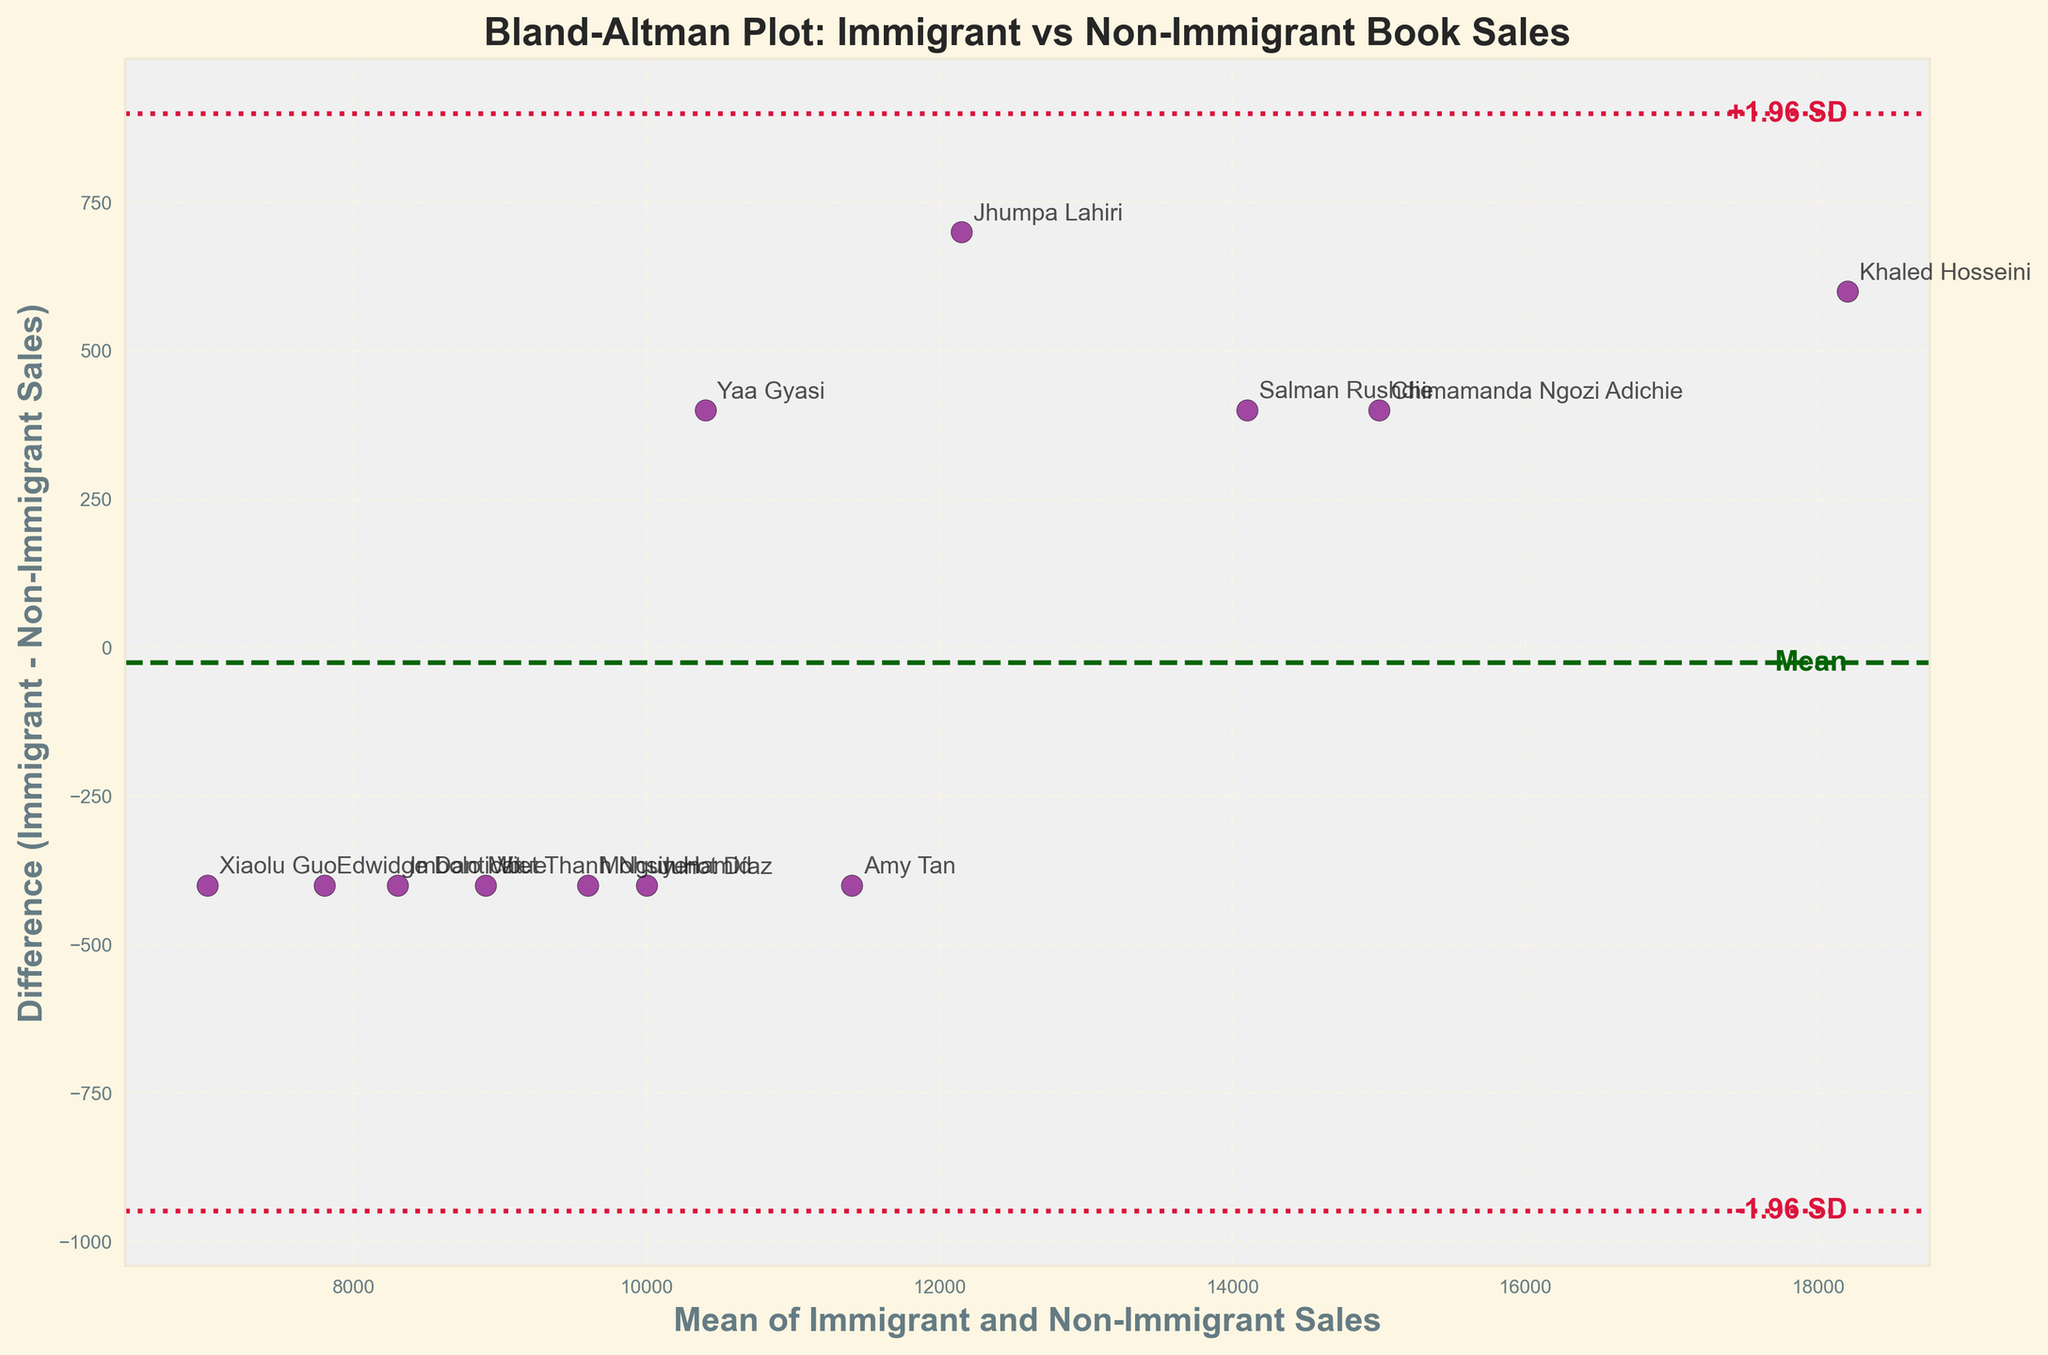What is the title of the plot? The title is displayed at the top of the plot and it reads "Bland-Altman Plot: Immigrant vs Non-Immigrant Book Sales."
Answer: Bland-Altman Plot: Immigrant vs Non-Immigrant Book Sales How many authors are represented in the plot? Each data point in the scatter plot represents an author. By counting these points or the annotations, we find there are 12 authors.
Answer: 12 What does the y-axis represent? The y-axis label reads "Difference (Immigrant - Non-Immigrant Sales)," indicating that it represents the difference in book sales between immigrant and non-immigrant authors.
Answer: Difference (Immigrant - Non-Immigrant Sales) What are the mean difference and standard deviation lines colored in the plot? The mean difference line is dashed and colored dark green, while the standard deviation lines (+1.96 SD and -1.96 SD) are dotted and colored crimson.
Answer: Dark green and crimson Which author has the largest positive difference between immigrant and non-immigrant sales? By looking at the highest point above the y=0 line, Khaled Hosseini has the largest positive difference, as his data point is the highest from the mean zero difference.
Answer: Khaled Hosseini What are the upper and lower limits of agreement? The upper and lower limits of agreement are denoted by the crimson dotted lines and annotated as "+1.96 SD" and "-1.96 SD," respectively.
Answer: Limits of agreement are marked as +1.96 SD and -1.96 SD Are there any authors with higher non-immigrant sales than immigrant sales? Authors with data points below the y=0 line have higher non-immigrant sales than immigrant sales. Examples include Xiaolu Guo and Imbolo Mbue.
Answer: Yes, Xiaolu Guo and Imbolo Mbue What is the mean difference in sales between immigrant and non-immigrant authors? The mean difference is represented by the dark green dashed line, which is labeled "Mean" in the plot.
Answer: Shown by the dashed dark green line Which author has the smallest absolute difference in sales between immigrant and non-immigrant sales? By locating the data point closest to the y=0 line, Amy Tan appears to have the smallest absolute difference.
Answer: Amy Tan How do the limits of agreement help in the interpretation of the data? The limits of agreement (±1.96 SD) show the range where most differences between immigrant and non-immigrant sales will fall. This helps determine the consistency or agreement between the two sale distributions.
Answer: Range of most differences; shows consistency or agreement 